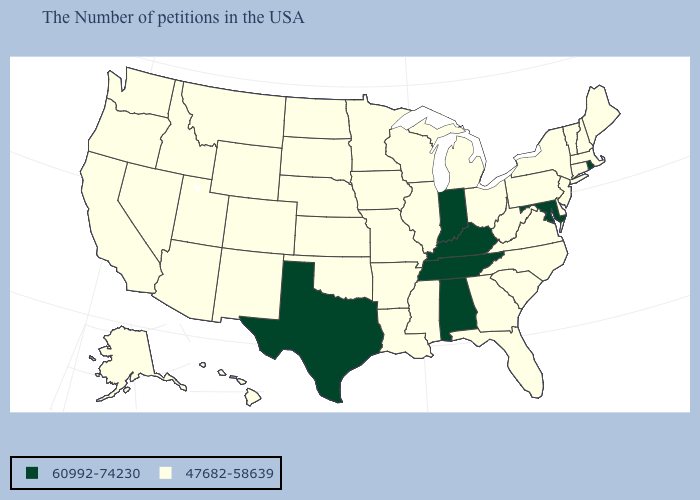Does Alabama have a higher value than Massachusetts?
Give a very brief answer. Yes. What is the lowest value in the USA?
Quick response, please. 47682-58639. Name the states that have a value in the range 47682-58639?
Give a very brief answer. Maine, Massachusetts, New Hampshire, Vermont, Connecticut, New York, New Jersey, Delaware, Pennsylvania, Virginia, North Carolina, South Carolina, West Virginia, Ohio, Florida, Georgia, Michigan, Wisconsin, Illinois, Mississippi, Louisiana, Missouri, Arkansas, Minnesota, Iowa, Kansas, Nebraska, Oklahoma, South Dakota, North Dakota, Wyoming, Colorado, New Mexico, Utah, Montana, Arizona, Idaho, Nevada, California, Washington, Oregon, Alaska, Hawaii. What is the value of Colorado?
Concise answer only. 47682-58639. What is the highest value in the USA?
Short answer required. 60992-74230. Does the map have missing data?
Short answer required. No. What is the lowest value in the USA?
Concise answer only. 47682-58639. Does the first symbol in the legend represent the smallest category?
Write a very short answer. No. What is the value of Tennessee?
Keep it brief. 60992-74230. What is the value of Louisiana?
Keep it brief. 47682-58639. Among the states that border Kansas , which have the highest value?
Short answer required. Missouri, Nebraska, Oklahoma, Colorado. Which states have the lowest value in the South?
Be succinct. Delaware, Virginia, North Carolina, South Carolina, West Virginia, Florida, Georgia, Mississippi, Louisiana, Arkansas, Oklahoma. What is the lowest value in the West?
Give a very brief answer. 47682-58639. Does Utah have the same value as South Carolina?
Give a very brief answer. Yes. 